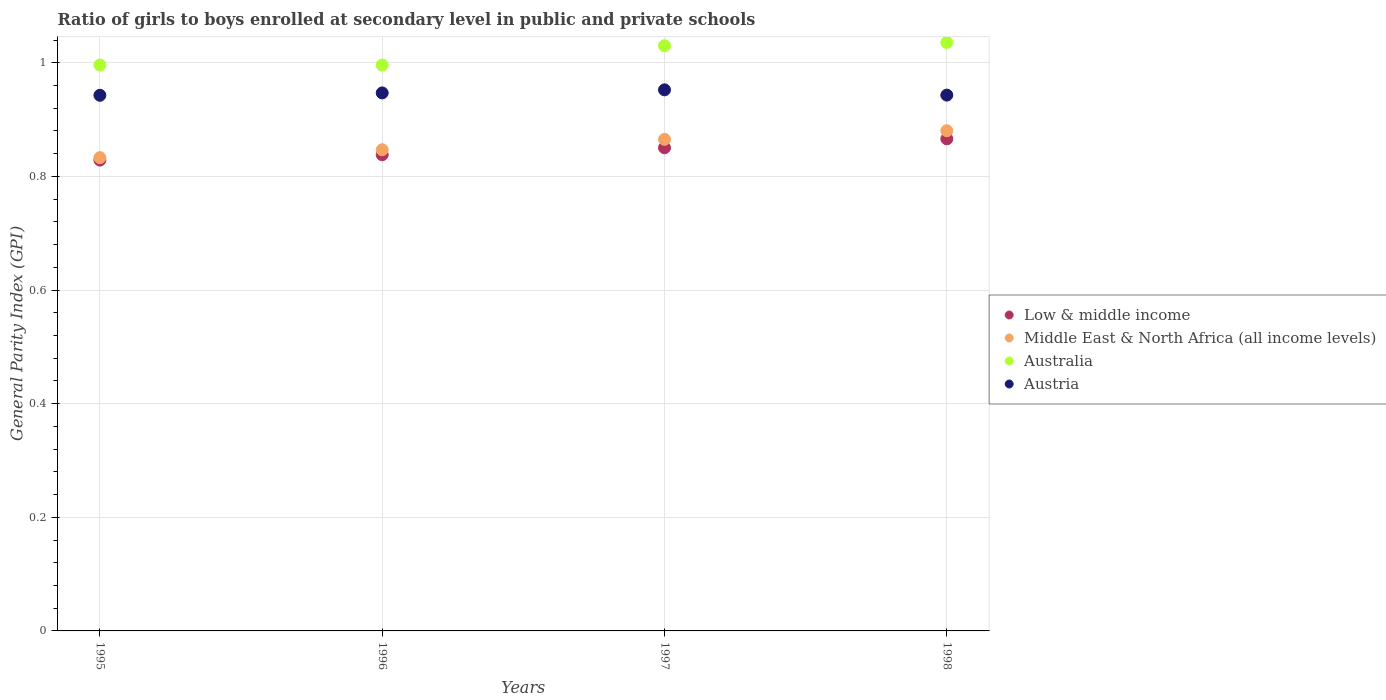How many different coloured dotlines are there?
Your answer should be very brief. 4. Is the number of dotlines equal to the number of legend labels?
Make the answer very short. Yes. What is the general parity index in Middle East & North Africa (all income levels) in 1995?
Your answer should be compact. 0.83. Across all years, what is the maximum general parity index in Low & middle income?
Offer a terse response. 0.87. Across all years, what is the minimum general parity index in Austria?
Make the answer very short. 0.94. In which year was the general parity index in Australia minimum?
Offer a terse response. 1996. What is the total general parity index in Australia in the graph?
Your answer should be very brief. 4.06. What is the difference between the general parity index in Middle East & North Africa (all income levels) in 1997 and that in 1998?
Provide a succinct answer. -0.02. What is the difference between the general parity index in Middle East & North Africa (all income levels) in 1998 and the general parity index in Australia in 1997?
Your answer should be very brief. -0.15. What is the average general parity index in Austria per year?
Offer a terse response. 0.95. In the year 1996, what is the difference between the general parity index in Austria and general parity index in Low & middle income?
Provide a short and direct response. 0.11. In how many years, is the general parity index in Australia greater than 0.56?
Your response must be concise. 4. What is the ratio of the general parity index in Austria in 1995 to that in 1996?
Keep it short and to the point. 1. Is the difference between the general parity index in Austria in 1997 and 1998 greater than the difference between the general parity index in Low & middle income in 1997 and 1998?
Keep it short and to the point. Yes. What is the difference between the highest and the second highest general parity index in Austria?
Ensure brevity in your answer.  0.01. What is the difference between the highest and the lowest general parity index in Australia?
Your answer should be compact. 0.04. Is it the case that in every year, the sum of the general parity index in Austria and general parity index in Middle East & North Africa (all income levels)  is greater than the sum of general parity index in Low & middle income and general parity index in Australia?
Provide a succinct answer. Yes. Is it the case that in every year, the sum of the general parity index in Low & middle income and general parity index in Australia  is greater than the general parity index in Middle East & North Africa (all income levels)?
Ensure brevity in your answer.  Yes. Does the general parity index in Austria monotonically increase over the years?
Offer a very short reply. No. How many dotlines are there?
Give a very brief answer. 4. How many years are there in the graph?
Offer a terse response. 4. What is the difference between two consecutive major ticks on the Y-axis?
Offer a very short reply. 0.2. Does the graph contain any zero values?
Provide a succinct answer. No. Does the graph contain grids?
Offer a very short reply. Yes. Where does the legend appear in the graph?
Provide a short and direct response. Center right. How are the legend labels stacked?
Your answer should be compact. Vertical. What is the title of the graph?
Give a very brief answer. Ratio of girls to boys enrolled at secondary level in public and private schools. What is the label or title of the X-axis?
Offer a very short reply. Years. What is the label or title of the Y-axis?
Ensure brevity in your answer.  General Parity Index (GPI). What is the General Parity Index (GPI) in Low & middle income in 1995?
Your answer should be very brief. 0.83. What is the General Parity Index (GPI) in Middle East & North Africa (all income levels) in 1995?
Make the answer very short. 0.83. What is the General Parity Index (GPI) of Australia in 1995?
Make the answer very short. 1. What is the General Parity Index (GPI) of Austria in 1995?
Provide a succinct answer. 0.94. What is the General Parity Index (GPI) of Low & middle income in 1996?
Your answer should be very brief. 0.84. What is the General Parity Index (GPI) of Middle East & North Africa (all income levels) in 1996?
Your response must be concise. 0.85. What is the General Parity Index (GPI) of Australia in 1996?
Give a very brief answer. 1. What is the General Parity Index (GPI) in Austria in 1996?
Your answer should be very brief. 0.95. What is the General Parity Index (GPI) in Low & middle income in 1997?
Give a very brief answer. 0.85. What is the General Parity Index (GPI) in Middle East & North Africa (all income levels) in 1997?
Give a very brief answer. 0.87. What is the General Parity Index (GPI) in Australia in 1997?
Your response must be concise. 1.03. What is the General Parity Index (GPI) of Austria in 1997?
Give a very brief answer. 0.95. What is the General Parity Index (GPI) in Low & middle income in 1998?
Your response must be concise. 0.87. What is the General Parity Index (GPI) of Middle East & North Africa (all income levels) in 1998?
Ensure brevity in your answer.  0.88. What is the General Parity Index (GPI) of Australia in 1998?
Make the answer very short. 1.04. What is the General Parity Index (GPI) in Austria in 1998?
Ensure brevity in your answer.  0.94. Across all years, what is the maximum General Parity Index (GPI) of Low & middle income?
Ensure brevity in your answer.  0.87. Across all years, what is the maximum General Parity Index (GPI) in Middle East & North Africa (all income levels)?
Your answer should be very brief. 0.88. Across all years, what is the maximum General Parity Index (GPI) in Australia?
Give a very brief answer. 1.04. Across all years, what is the maximum General Parity Index (GPI) of Austria?
Your answer should be compact. 0.95. Across all years, what is the minimum General Parity Index (GPI) in Low & middle income?
Offer a very short reply. 0.83. Across all years, what is the minimum General Parity Index (GPI) of Middle East & North Africa (all income levels)?
Keep it short and to the point. 0.83. Across all years, what is the minimum General Parity Index (GPI) in Australia?
Keep it short and to the point. 1. Across all years, what is the minimum General Parity Index (GPI) in Austria?
Give a very brief answer. 0.94. What is the total General Parity Index (GPI) of Low & middle income in the graph?
Keep it short and to the point. 3.38. What is the total General Parity Index (GPI) in Middle East & North Africa (all income levels) in the graph?
Ensure brevity in your answer.  3.43. What is the total General Parity Index (GPI) of Australia in the graph?
Offer a terse response. 4.06. What is the total General Parity Index (GPI) of Austria in the graph?
Your response must be concise. 3.79. What is the difference between the General Parity Index (GPI) in Low & middle income in 1995 and that in 1996?
Keep it short and to the point. -0.01. What is the difference between the General Parity Index (GPI) in Middle East & North Africa (all income levels) in 1995 and that in 1996?
Offer a terse response. -0.01. What is the difference between the General Parity Index (GPI) in Austria in 1995 and that in 1996?
Ensure brevity in your answer.  -0. What is the difference between the General Parity Index (GPI) of Low & middle income in 1995 and that in 1997?
Offer a terse response. -0.02. What is the difference between the General Parity Index (GPI) in Middle East & North Africa (all income levels) in 1995 and that in 1997?
Keep it short and to the point. -0.03. What is the difference between the General Parity Index (GPI) of Australia in 1995 and that in 1997?
Offer a very short reply. -0.03. What is the difference between the General Parity Index (GPI) in Austria in 1995 and that in 1997?
Your answer should be very brief. -0.01. What is the difference between the General Parity Index (GPI) of Low & middle income in 1995 and that in 1998?
Provide a succinct answer. -0.04. What is the difference between the General Parity Index (GPI) of Middle East & North Africa (all income levels) in 1995 and that in 1998?
Your response must be concise. -0.05. What is the difference between the General Parity Index (GPI) of Australia in 1995 and that in 1998?
Your answer should be compact. -0.04. What is the difference between the General Parity Index (GPI) of Austria in 1995 and that in 1998?
Ensure brevity in your answer.  -0. What is the difference between the General Parity Index (GPI) in Low & middle income in 1996 and that in 1997?
Provide a short and direct response. -0.01. What is the difference between the General Parity Index (GPI) of Middle East & North Africa (all income levels) in 1996 and that in 1997?
Offer a terse response. -0.02. What is the difference between the General Parity Index (GPI) in Australia in 1996 and that in 1997?
Make the answer very short. -0.03. What is the difference between the General Parity Index (GPI) in Austria in 1996 and that in 1997?
Provide a short and direct response. -0.01. What is the difference between the General Parity Index (GPI) in Low & middle income in 1996 and that in 1998?
Provide a short and direct response. -0.03. What is the difference between the General Parity Index (GPI) in Middle East & North Africa (all income levels) in 1996 and that in 1998?
Offer a terse response. -0.03. What is the difference between the General Parity Index (GPI) of Australia in 1996 and that in 1998?
Offer a very short reply. -0.04. What is the difference between the General Parity Index (GPI) of Austria in 1996 and that in 1998?
Provide a short and direct response. 0. What is the difference between the General Parity Index (GPI) of Low & middle income in 1997 and that in 1998?
Your answer should be compact. -0.02. What is the difference between the General Parity Index (GPI) of Middle East & North Africa (all income levels) in 1997 and that in 1998?
Your answer should be compact. -0.02. What is the difference between the General Parity Index (GPI) of Australia in 1997 and that in 1998?
Your answer should be very brief. -0.01. What is the difference between the General Parity Index (GPI) in Austria in 1997 and that in 1998?
Offer a terse response. 0.01. What is the difference between the General Parity Index (GPI) of Low & middle income in 1995 and the General Parity Index (GPI) of Middle East & North Africa (all income levels) in 1996?
Ensure brevity in your answer.  -0.02. What is the difference between the General Parity Index (GPI) in Low & middle income in 1995 and the General Parity Index (GPI) in Australia in 1996?
Your response must be concise. -0.17. What is the difference between the General Parity Index (GPI) in Low & middle income in 1995 and the General Parity Index (GPI) in Austria in 1996?
Your response must be concise. -0.12. What is the difference between the General Parity Index (GPI) of Middle East & North Africa (all income levels) in 1995 and the General Parity Index (GPI) of Australia in 1996?
Give a very brief answer. -0.16. What is the difference between the General Parity Index (GPI) in Middle East & North Africa (all income levels) in 1995 and the General Parity Index (GPI) in Austria in 1996?
Keep it short and to the point. -0.11. What is the difference between the General Parity Index (GPI) of Australia in 1995 and the General Parity Index (GPI) of Austria in 1996?
Provide a succinct answer. 0.05. What is the difference between the General Parity Index (GPI) of Low & middle income in 1995 and the General Parity Index (GPI) of Middle East & North Africa (all income levels) in 1997?
Keep it short and to the point. -0.04. What is the difference between the General Parity Index (GPI) of Low & middle income in 1995 and the General Parity Index (GPI) of Australia in 1997?
Keep it short and to the point. -0.2. What is the difference between the General Parity Index (GPI) in Low & middle income in 1995 and the General Parity Index (GPI) in Austria in 1997?
Ensure brevity in your answer.  -0.12. What is the difference between the General Parity Index (GPI) of Middle East & North Africa (all income levels) in 1995 and the General Parity Index (GPI) of Australia in 1997?
Offer a terse response. -0.2. What is the difference between the General Parity Index (GPI) of Middle East & North Africa (all income levels) in 1995 and the General Parity Index (GPI) of Austria in 1997?
Provide a succinct answer. -0.12. What is the difference between the General Parity Index (GPI) in Australia in 1995 and the General Parity Index (GPI) in Austria in 1997?
Your answer should be very brief. 0.04. What is the difference between the General Parity Index (GPI) of Low & middle income in 1995 and the General Parity Index (GPI) of Middle East & North Africa (all income levels) in 1998?
Your answer should be compact. -0.05. What is the difference between the General Parity Index (GPI) in Low & middle income in 1995 and the General Parity Index (GPI) in Australia in 1998?
Your answer should be compact. -0.21. What is the difference between the General Parity Index (GPI) of Low & middle income in 1995 and the General Parity Index (GPI) of Austria in 1998?
Offer a very short reply. -0.11. What is the difference between the General Parity Index (GPI) in Middle East & North Africa (all income levels) in 1995 and the General Parity Index (GPI) in Australia in 1998?
Provide a succinct answer. -0.2. What is the difference between the General Parity Index (GPI) of Middle East & North Africa (all income levels) in 1995 and the General Parity Index (GPI) of Austria in 1998?
Your response must be concise. -0.11. What is the difference between the General Parity Index (GPI) in Australia in 1995 and the General Parity Index (GPI) in Austria in 1998?
Offer a terse response. 0.05. What is the difference between the General Parity Index (GPI) in Low & middle income in 1996 and the General Parity Index (GPI) in Middle East & North Africa (all income levels) in 1997?
Keep it short and to the point. -0.03. What is the difference between the General Parity Index (GPI) of Low & middle income in 1996 and the General Parity Index (GPI) of Australia in 1997?
Offer a very short reply. -0.19. What is the difference between the General Parity Index (GPI) in Low & middle income in 1996 and the General Parity Index (GPI) in Austria in 1997?
Make the answer very short. -0.11. What is the difference between the General Parity Index (GPI) in Middle East & North Africa (all income levels) in 1996 and the General Parity Index (GPI) in Australia in 1997?
Make the answer very short. -0.18. What is the difference between the General Parity Index (GPI) in Middle East & North Africa (all income levels) in 1996 and the General Parity Index (GPI) in Austria in 1997?
Offer a terse response. -0.11. What is the difference between the General Parity Index (GPI) in Australia in 1996 and the General Parity Index (GPI) in Austria in 1997?
Provide a succinct answer. 0.04. What is the difference between the General Parity Index (GPI) of Low & middle income in 1996 and the General Parity Index (GPI) of Middle East & North Africa (all income levels) in 1998?
Keep it short and to the point. -0.04. What is the difference between the General Parity Index (GPI) of Low & middle income in 1996 and the General Parity Index (GPI) of Australia in 1998?
Provide a succinct answer. -0.2. What is the difference between the General Parity Index (GPI) of Low & middle income in 1996 and the General Parity Index (GPI) of Austria in 1998?
Ensure brevity in your answer.  -0.1. What is the difference between the General Parity Index (GPI) in Middle East & North Africa (all income levels) in 1996 and the General Parity Index (GPI) in Australia in 1998?
Offer a terse response. -0.19. What is the difference between the General Parity Index (GPI) in Middle East & North Africa (all income levels) in 1996 and the General Parity Index (GPI) in Austria in 1998?
Give a very brief answer. -0.1. What is the difference between the General Parity Index (GPI) of Australia in 1996 and the General Parity Index (GPI) of Austria in 1998?
Provide a short and direct response. 0.05. What is the difference between the General Parity Index (GPI) in Low & middle income in 1997 and the General Parity Index (GPI) in Middle East & North Africa (all income levels) in 1998?
Your answer should be very brief. -0.03. What is the difference between the General Parity Index (GPI) in Low & middle income in 1997 and the General Parity Index (GPI) in Australia in 1998?
Make the answer very short. -0.19. What is the difference between the General Parity Index (GPI) in Low & middle income in 1997 and the General Parity Index (GPI) in Austria in 1998?
Make the answer very short. -0.09. What is the difference between the General Parity Index (GPI) of Middle East & North Africa (all income levels) in 1997 and the General Parity Index (GPI) of Australia in 1998?
Your answer should be compact. -0.17. What is the difference between the General Parity Index (GPI) of Middle East & North Africa (all income levels) in 1997 and the General Parity Index (GPI) of Austria in 1998?
Ensure brevity in your answer.  -0.08. What is the difference between the General Parity Index (GPI) in Australia in 1997 and the General Parity Index (GPI) in Austria in 1998?
Your answer should be compact. 0.09. What is the average General Parity Index (GPI) in Low & middle income per year?
Your response must be concise. 0.85. What is the average General Parity Index (GPI) in Middle East & North Africa (all income levels) per year?
Give a very brief answer. 0.86. What is the average General Parity Index (GPI) in Australia per year?
Offer a terse response. 1.01. What is the average General Parity Index (GPI) of Austria per year?
Your answer should be compact. 0.95. In the year 1995, what is the difference between the General Parity Index (GPI) in Low & middle income and General Parity Index (GPI) in Middle East & North Africa (all income levels)?
Offer a terse response. -0. In the year 1995, what is the difference between the General Parity Index (GPI) of Low & middle income and General Parity Index (GPI) of Australia?
Your response must be concise. -0.17. In the year 1995, what is the difference between the General Parity Index (GPI) of Low & middle income and General Parity Index (GPI) of Austria?
Your answer should be very brief. -0.11. In the year 1995, what is the difference between the General Parity Index (GPI) in Middle East & North Africa (all income levels) and General Parity Index (GPI) in Australia?
Make the answer very short. -0.16. In the year 1995, what is the difference between the General Parity Index (GPI) in Middle East & North Africa (all income levels) and General Parity Index (GPI) in Austria?
Your response must be concise. -0.11. In the year 1995, what is the difference between the General Parity Index (GPI) of Australia and General Parity Index (GPI) of Austria?
Your answer should be compact. 0.05. In the year 1996, what is the difference between the General Parity Index (GPI) of Low & middle income and General Parity Index (GPI) of Middle East & North Africa (all income levels)?
Your response must be concise. -0.01. In the year 1996, what is the difference between the General Parity Index (GPI) of Low & middle income and General Parity Index (GPI) of Australia?
Provide a succinct answer. -0.16. In the year 1996, what is the difference between the General Parity Index (GPI) in Low & middle income and General Parity Index (GPI) in Austria?
Ensure brevity in your answer.  -0.11. In the year 1996, what is the difference between the General Parity Index (GPI) in Middle East & North Africa (all income levels) and General Parity Index (GPI) in Australia?
Your answer should be very brief. -0.15. In the year 1996, what is the difference between the General Parity Index (GPI) in Middle East & North Africa (all income levels) and General Parity Index (GPI) in Austria?
Give a very brief answer. -0.1. In the year 1996, what is the difference between the General Parity Index (GPI) in Australia and General Parity Index (GPI) in Austria?
Make the answer very short. 0.05. In the year 1997, what is the difference between the General Parity Index (GPI) of Low & middle income and General Parity Index (GPI) of Middle East & North Africa (all income levels)?
Provide a short and direct response. -0.01. In the year 1997, what is the difference between the General Parity Index (GPI) in Low & middle income and General Parity Index (GPI) in Australia?
Your answer should be very brief. -0.18. In the year 1997, what is the difference between the General Parity Index (GPI) of Low & middle income and General Parity Index (GPI) of Austria?
Give a very brief answer. -0.1. In the year 1997, what is the difference between the General Parity Index (GPI) in Middle East & North Africa (all income levels) and General Parity Index (GPI) in Australia?
Offer a terse response. -0.16. In the year 1997, what is the difference between the General Parity Index (GPI) of Middle East & North Africa (all income levels) and General Parity Index (GPI) of Austria?
Your response must be concise. -0.09. In the year 1997, what is the difference between the General Parity Index (GPI) of Australia and General Parity Index (GPI) of Austria?
Your answer should be very brief. 0.08. In the year 1998, what is the difference between the General Parity Index (GPI) in Low & middle income and General Parity Index (GPI) in Middle East & North Africa (all income levels)?
Make the answer very short. -0.01. In the year 1998, what is the difference between the General Parity Index (GPI) of Low & middle income and General Parity Index (GPI) of Australia?
Provide a short and direct response. -0.17. In the year 1998, what is the difference between the General Parity Index (GPI) in Low & middle income and General Parity Index (GPI) in Austria?
Make the answer very short. -0.08. In the year 1998, what is the difference between the General Parity Index (GPI) of Middle East & North Africa (all income levels) and General Parity Index (GPI) of Australia?
Your response must be concise. -0.16. In the year 1998, what is the difference between the General Parity Index (GPI) of Middle East & North Africa (all income levels) and General Parity Index (GPI) of Austria?
Provide a short and direct response. -0.06. In the year 1998, what is the difference between the General Parity Index (GPI) of Australia and General Parity Index (GPI) of Austria?
Your answer should be compact. 0.09. What is the ratio of the General Parity Index (GPI) of Low & middle income in 1995 to that in 1996?
Provide a succinct answer. 0.99. What is the ratio of the General Parity Index (GPI) in Middle East & North Africa (all income levels) in 1995 to that in 1996?
Ensure brevity in your answer.  0.98. What is the ratio of the General Parity Index (GPI) in Australia in 1995 to that in 1996?
Provide a succinct answer. 1. What is the ratio of the General Parity Index (GPI) of Low & middle income in 1995 to that in 1997?
Keep it short and to the point. 0.97. What is the ratio of the General Parity Index (GPI) of Middle East & North Africa (all income levels) in 1995 to that in 1997?
Ensure brevity in your answer.  0.96. What is the ratio of the General Parity Index (GPI) of Australia in 1995 to that in 1997?
Your answer should be very brief. 0.97. What is the ratio of the General Parity Index (GPI) of Low & middle income in 1995 to that in 1998?
Make the answer very short. 0.96. What is the ratio of the General Parity Index (GPI) in Middle East & North Africa (all income levels) in 1995 to that in 1998?
Your answer should be compact. 0.95. What is the ratio of the General Parity Index (GPI) of Australia in 1995 to that in 1998?
Your response must be concise. 0.96. What is the ratio of the General Parity Index (GPI) of Austria in 1995 to that in 1998?
Offer a very short reply. 1. What is the ratio of the General Parity Index (GPI) in Low & middle income in 1996 to that in 1997?
Ensure brevity in your answer.  0.99. What is the ratio of the General Parity Index (GPI) in Middle East & North Africa (all income levels) in 1996 to that in 1997?
Offer a very short reply. 0.98. What is the ratio of the General Parity Index (GPI) of Low & middle income in 1996 to that in 1998?
Make the answer very short. 0.97. What is the ratio of the General Parity Index (GPI) of Australia in 1996 to that in 1998?
Make the answer very short. 0.96. What is the ratio of the General Parity Index (GPI) in Low & middle income in 1997 to that in 1998?
Make the answer very short. 0.98. What is the ratio of the General Parity Index (GPI) of Middle East & North Africa (all income levels) in 1997 to that in 1998?
Provide a short and direct response. 0.98. What is the ratio of the General Parity Index (GPI) in Australia in 1997 to that in 1998?
Provide a succinct answer. 0.99. What is the ratio of the General Parity Index (GPI) in Austria in 1997 to that in 1998?
Offer a terse response. 1.01. What is the difference between the highest and the second highest General Parity Index (GPI) of Low & middle income?
Provide a succinct answer. 0.02. What is the difference between the highest and the second highest General Parity Index (GPI) of Middle East & North Africa (all income levels)?
Your answer should be compact. 0.02. What is the difference between the highest and the second highest General Parity Index (GPI) in Australia?
Provide a succinct answer. 0.01. What is the difference between the highest and the second highest General Parity Index (GPI) in Austria?
Keep it short and to the point. 0.01. What is the difference between the highest and the lowest General Parity Index (GPI) in Low & middle income?
Ensure brevity in your answer.  0.04. What is the difference between the highest and the lowest General Parity Index (GPI) in Middle East & North Africa (all income levels)?
Provide a short and direct response. 0.05. What is the difference between the highest and the lowest General Parity Index (GPI) in Australia?
Your response must be concise. 0.04. What is the difference between the highest and the lowest General Parity Index (GPI) in Austria?
Keep it short and to the point. 0.01. 